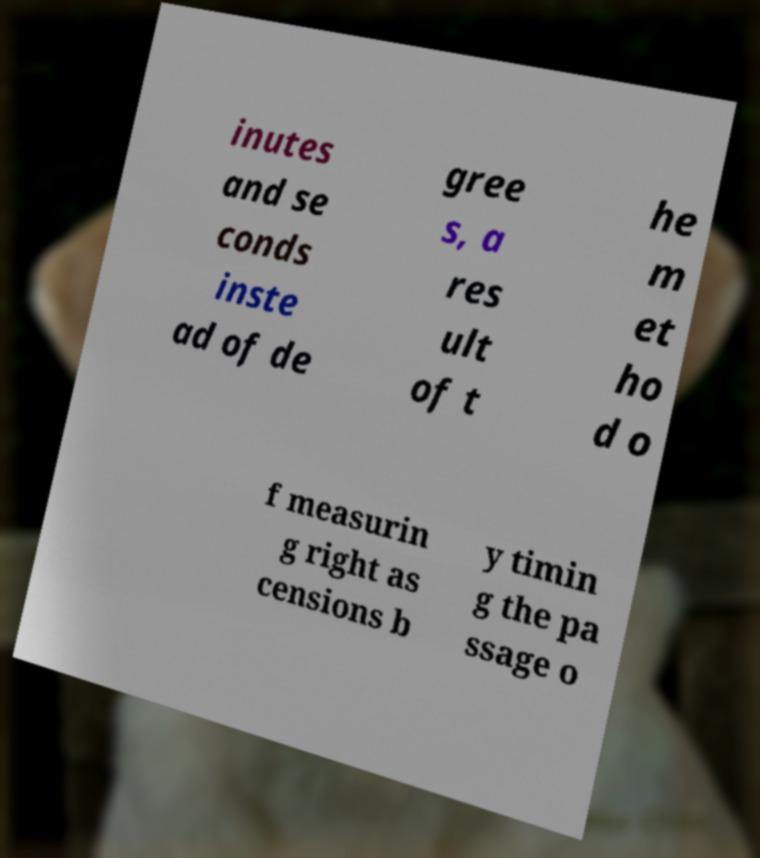What messages or text are displayed in this image? I need them in a readable, typed format. inutes and se conds inste ad of de gree s, a res ult of t he m et ho d o f measurin g right as censions b y timin g the pa ssage o 